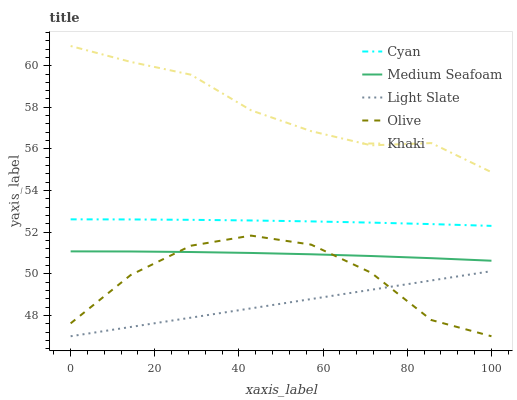Does Cyan have the minimum area under the curve?
Answer yes or no. No. Does Cyan have the maximum area under the curve?
Answer yes or no. No. Is Cyan the smoothest?
Answer yes or no. No. Is Cyan the roughest?
Answer yes or no. No. Does Cyan have the lowest value?
Answer yes or no. No. Does Cyan have the highest value?
Answer yes or no. No. Is Light Slate less than Khaki?
Answer yes or no. Yes. Is Khaki greater than Cyan?
Answer yes or no. Yes. Does Light Slate intersect Khaki?
Answer yes or no. No. 